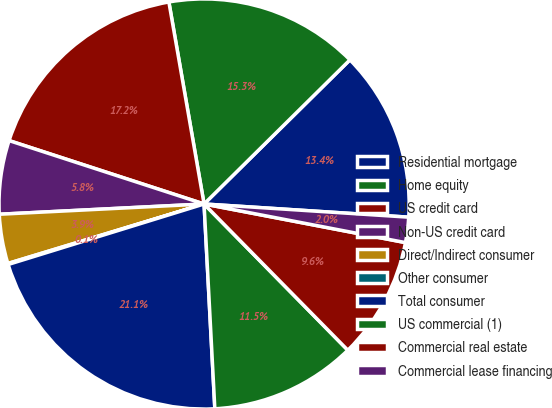Convert chart to OTSL. <chart><loc_0><loc_0><loc_500><loc_500><pie_chart><fcel>Residential mortgage<fcel>Home equity<fcel>US credit card<fcel>Non-US credit card<fcel>Direct/Indirect consumer<fcel>Other consumer<fcel>Total consumer<fcel>US commercial (1)<fcel>Commercial real estate<fcel>Commercial lease financing<nl><fcel>13.43%<fcel>15.34%<fcel>17.25%<fcel>5.8%<fcel>3.89%<fcel>0.08%<fcel>21.07%<fcel>11.53%<fcel>9.62%<fcel>1.99%<nl></chart> 